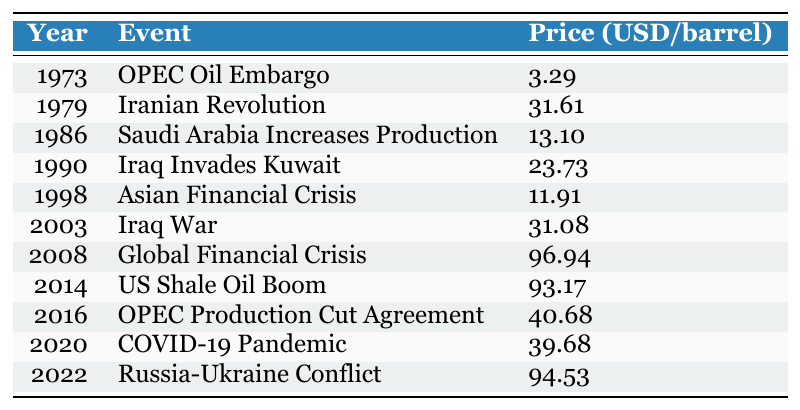What was the price of crude oil in 1973 after the OPEC Oil Embargo? The table indicates that in 1973, following the OPEC Oil Embargo, the price of crude oil was 3.29 USD per barrel.
Answer: 3.29 USD/barrel What major event occurred in 2008 that led to a high oil price? According to the table, the Global Financial Crisis occurred in 2008, which is associated with a high crude oil price of 96.94 USD per barrel.
Answer: Global Financial Crisis What was the difference in oil prices between the years 1998 and 2003? From the table, the price in 1998 was 11.91 USD/barrel and in 2003 it was 31.08 USD/barrel. The difference is calculated as 31.08 - 11.91 = 19.17 USD/barrel.
Answer: 19.17 USD/barrel Is it true that the price of crude oil decreased after the Iranian Revolution? The table shows that the price of crude oil was 31.61 USD/barrel in 1979 (after the Iranian Revolution) and increased in 1986 to 13.10 USD/barrel. This indicates the price did not decrease as mentioned; it is false.
Answer: False What was the average price of crude oil from 2000 to 2020? The prices for the years of interest are: 2003 (31.08), 2008 (96.94), 2014 (93.17), 2016 (40.68), and 2020 (39.68). Summing these up gives: 31.08 + 96.94 + 93.17 + 40.68 + 39.68 = 301.55. Since there are 5 years, the average is 301.55 / 5 = 60.31 USD/barrel.
Answer: 60.31 USD/barrel How did the oil price in 2022 compare to the price in 2014? The table indicates the price in 2014 was 93.17 USD/barrel and in 2022 during the Russia-Ukraine Conflict it was 94.53 USD/barrel. The price in 2022 was higher than in 2014.
Answer: Higher What was the correlation between the major events and oil prices from 1973 to 2022? The key events causing fluctuations are highlighted; typically geopolitical events (like wars or treaties) correspond with spikes in prices, as seen with the Iraq War in 2003 (31.08) or the ongoing Russia-Ukraine conflict in 2022 (94.53). A detailed examination would show volatility due to supply concerns, showing a positive correlation.
Answer: Positive correlation What were the prices during the lowest and highest recorded events, and what were these events? The lowest price was 11.91 USD/barrel in 1998 during the Asian Financial Crisis, and the highest was 96.94 USD/barrel in 2008 during the Global Financial Crisis.
Answer: Lowest: 11.91 USD/barrel (Asian Financial Crisis), Highest: 96.94 USD/barrel (Global Financial Crisis) In what year did oil prices first exceed $30 per barrel, and what event coincided with it? The table shows that the price exceeded $30 for the first time in 1979, coinciding with the Iranian Revolution.
Answer: 1979, Iranian Revolution 